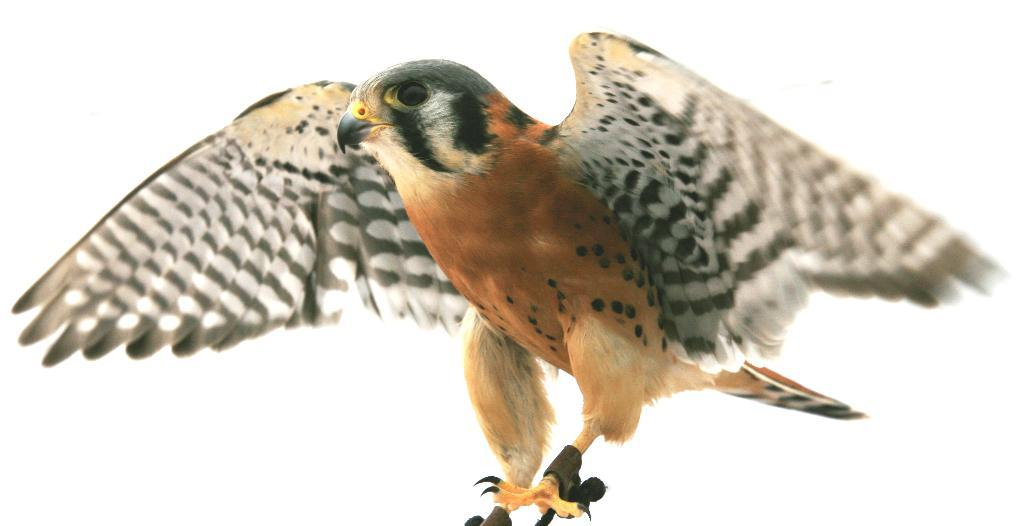What type of animal is present in the image? There is a bird in the image. What color is the background of the image? The background of the image is white. How many grapes can be seen hanging from the bird's beak in the image? There are no grapes present in the image, and the bird's beak is not visible. What type of crime is being committed in the image? There is no crime being committed in the image; it features a bird against a white background. 